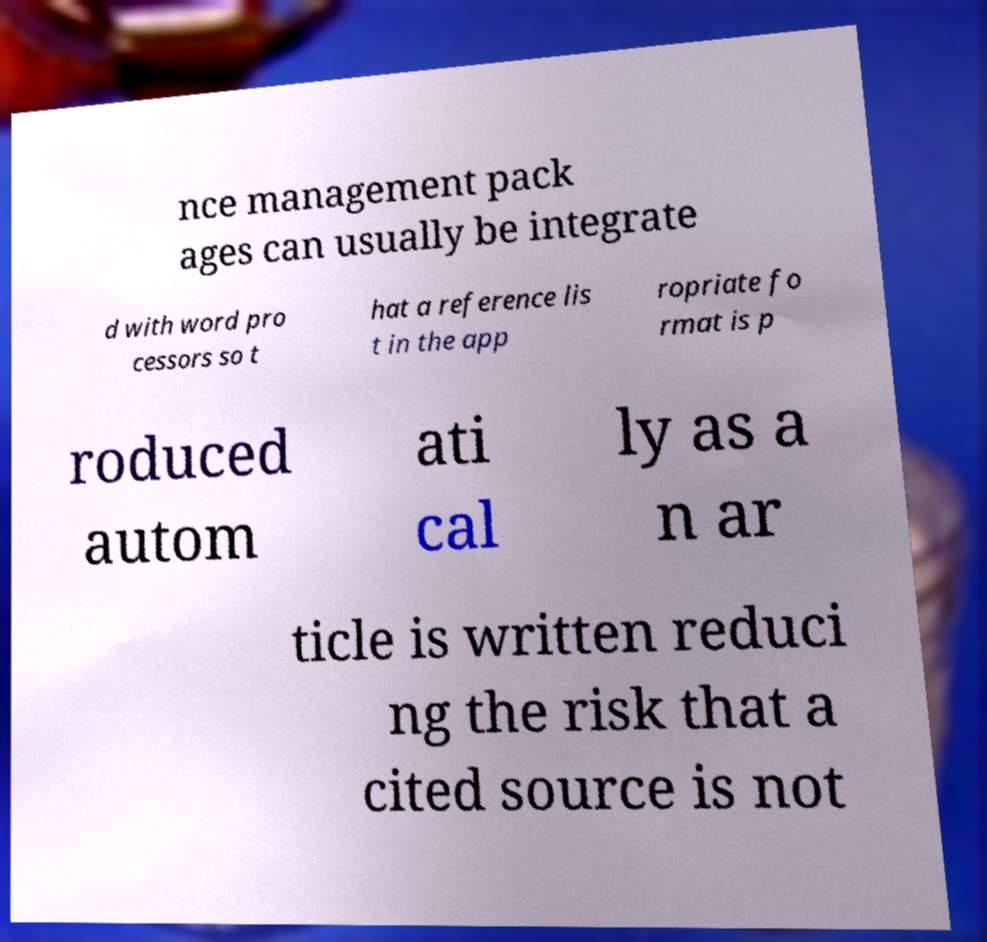What messages or text are displayed in this image? I need them in a readable, typed format. nce management pack ages can usually be integrate d with word pro cessors so t hat a reference lis t in the app ropriate fo rmat is p roduced autom ati cal ly as a n ar ticle is written reduci ng the risk that a cited source is not 